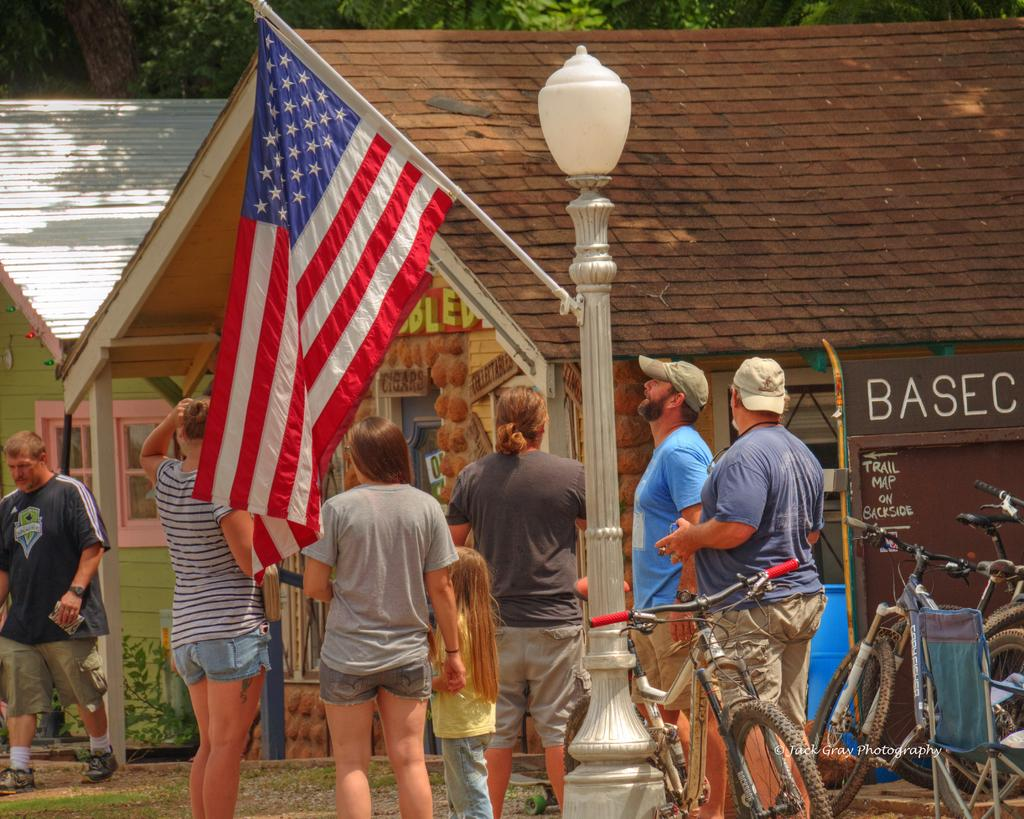What are the people in the image doing? The persons standing on the ground in the image are likely walking or standing. What type of structure can be seen in the image? There is a building in the image. What natural elements are present in the image? There are trees and plants in the image. What mode of transportation can be seen in the image? There are bicycles in the image. What is the purpose of the street pole in the image? The street pole in the image is likely used for supporting street lights and other signage, such as the flag attached to it. What type of lighting is present in the image? There is a street light in the image. What type of branch can be seen attacking the building in the image? There is no branch or attack present in the image. What material is the flag made of in the image? The material of the flag is not mentioned in the provided facts, so it cannot be determined from the image. 